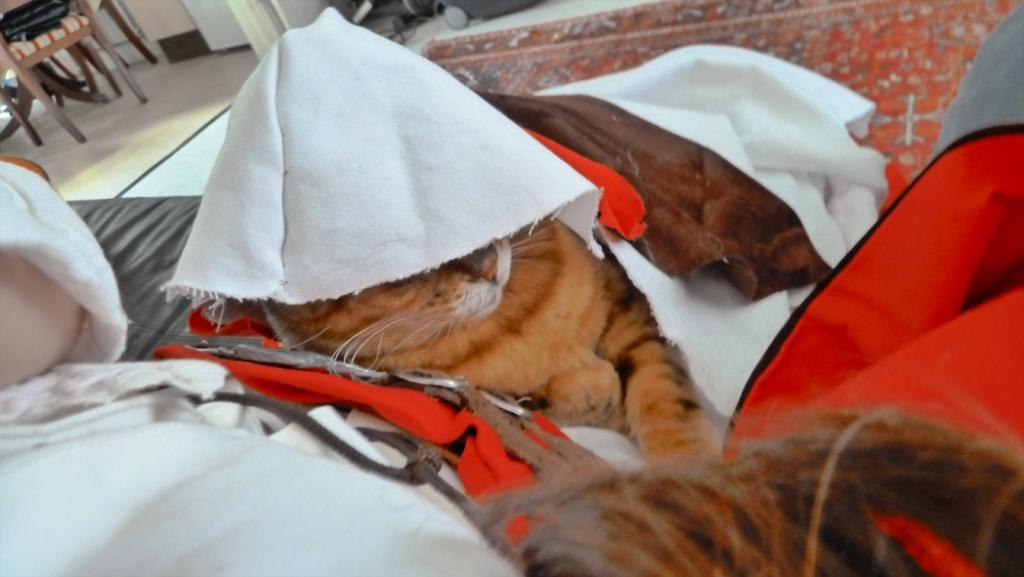What type of living creature is in the image? There is an animal in the image. What else can be seen in the image besides the animal? There are clothes and objects in the image. Can you describe the setting in which the animal is located? The background of the image includes a floor and a wall. Are there any other objects visible in the background of the image? Yes, there are additional objects in the background of the image. How many sacks are being carried by the horses in the image? There are no horses or sacks present in the image. What type of trousers is the animal wearing in the image? The animal in the image is not wearing any trousers. 